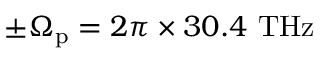Convert formula to latex. <formula><loc_0><loc_0><loc_500><loc_500>\pm \Omega _ { p } = 2 \pi \times 3 0 . 4 T H z</formula> 